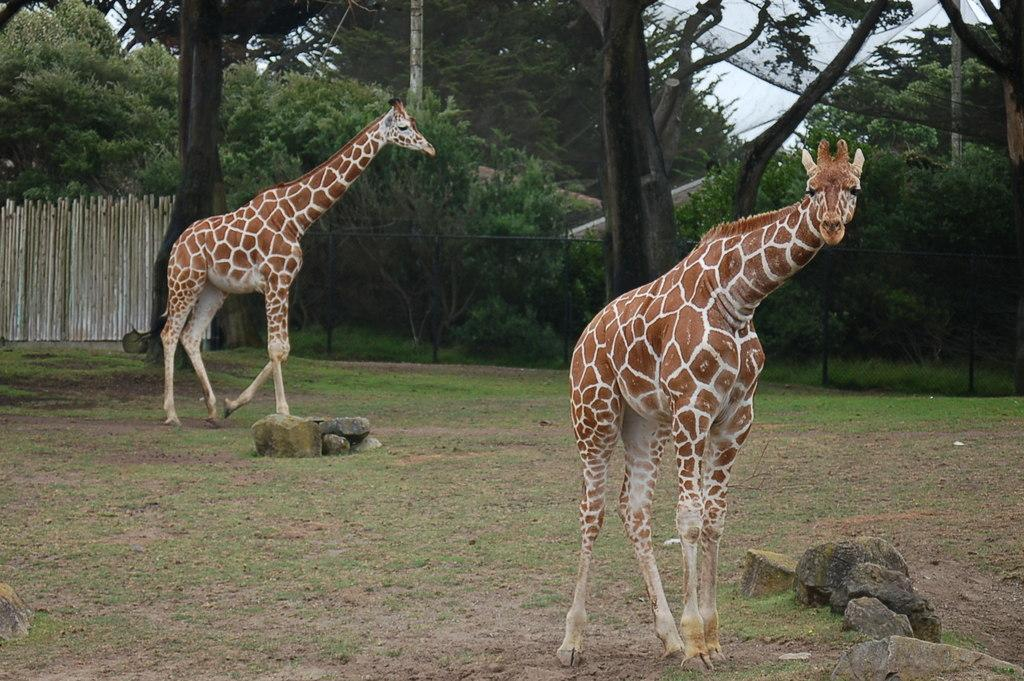How many animals are present in the image? There are two animals in the image. What colors are the animals? The animals are in brown and white color. What can be seen in the background of the image? There are trees and the sky visible in the background of the image. What is the color of the trees? The trees are green in color. What is the color of the sky? The sky is white in color. What type of insurance policy is being discussed by the animals in the image? There is no indication in the image that the animals are discussing any insurance policies. 